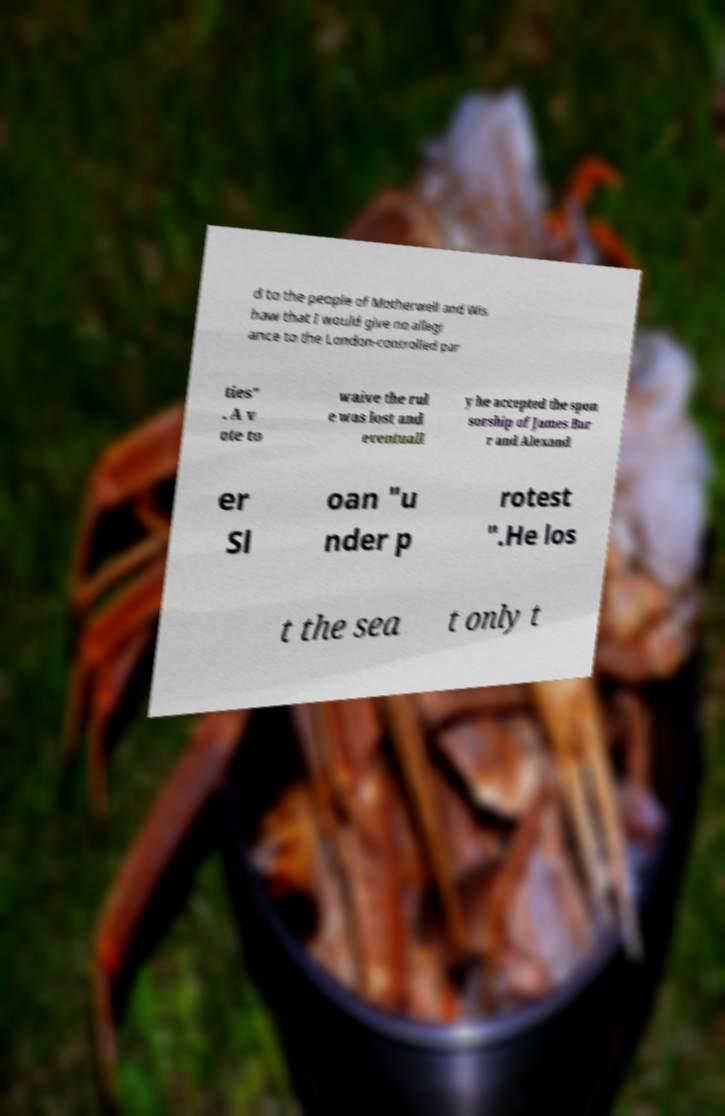Can you read and provide the text displayed in the image?This photo seems to have some interesting text. Can you extract and type it out for me? d to the people of Motherwell and Wis haw that I would give no allegi ance to the London-controlled par ties" . A v ote to waive the rul e was lost and eventuall y he accepted the spon sorship of James Bar r and Alexand er Sl oan "u nder p rotest ".He los t the sea t only t 